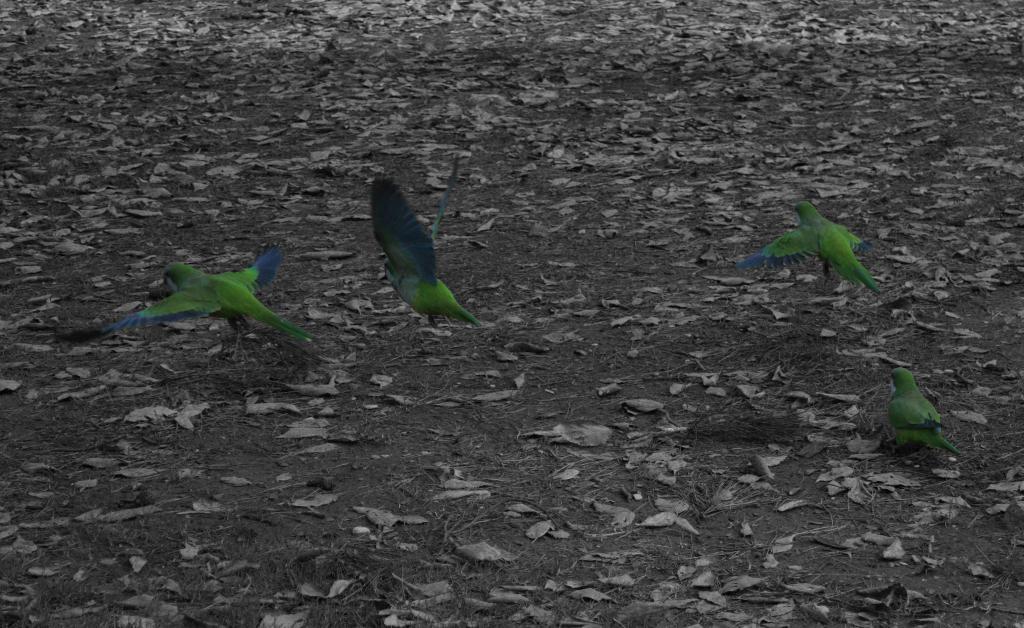In one or two sentences, can you explain what this image depicts? There are four green color parrots. Three of them are flying in the air and the remaining one is standing on the ground,on which, there are dry leaves. 